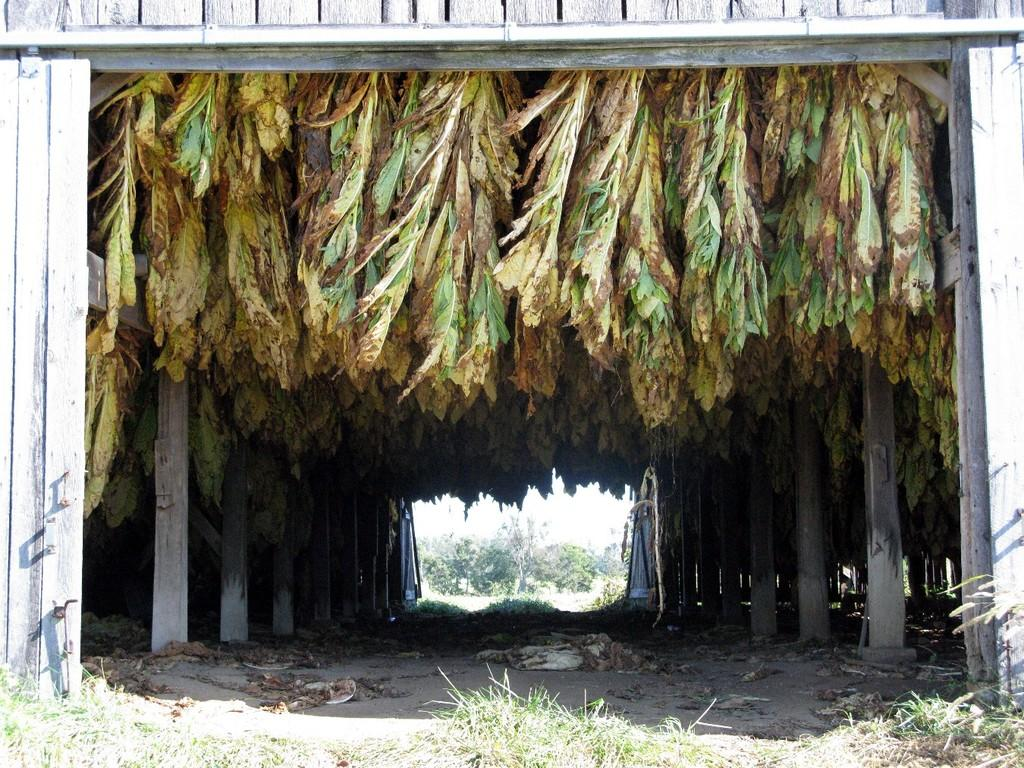What type of wall is visible in the image? There is a wooden wall in the image. What can be seen in the middle of the image? There are leaves in the middle of the image. What architectural features are present on the left side of the image? There are pillars on the left side of the image. What architectural features are present on the right side of the image? There are pillars on the right side of the image. What type of loaf is being baked in the image? There is no loaf present in the image; it features a wooden wall, leaves, and pillars. What facial expression can be seen on the pillars in the image? There are no faces or facial expressions present on the pillars in the image. 